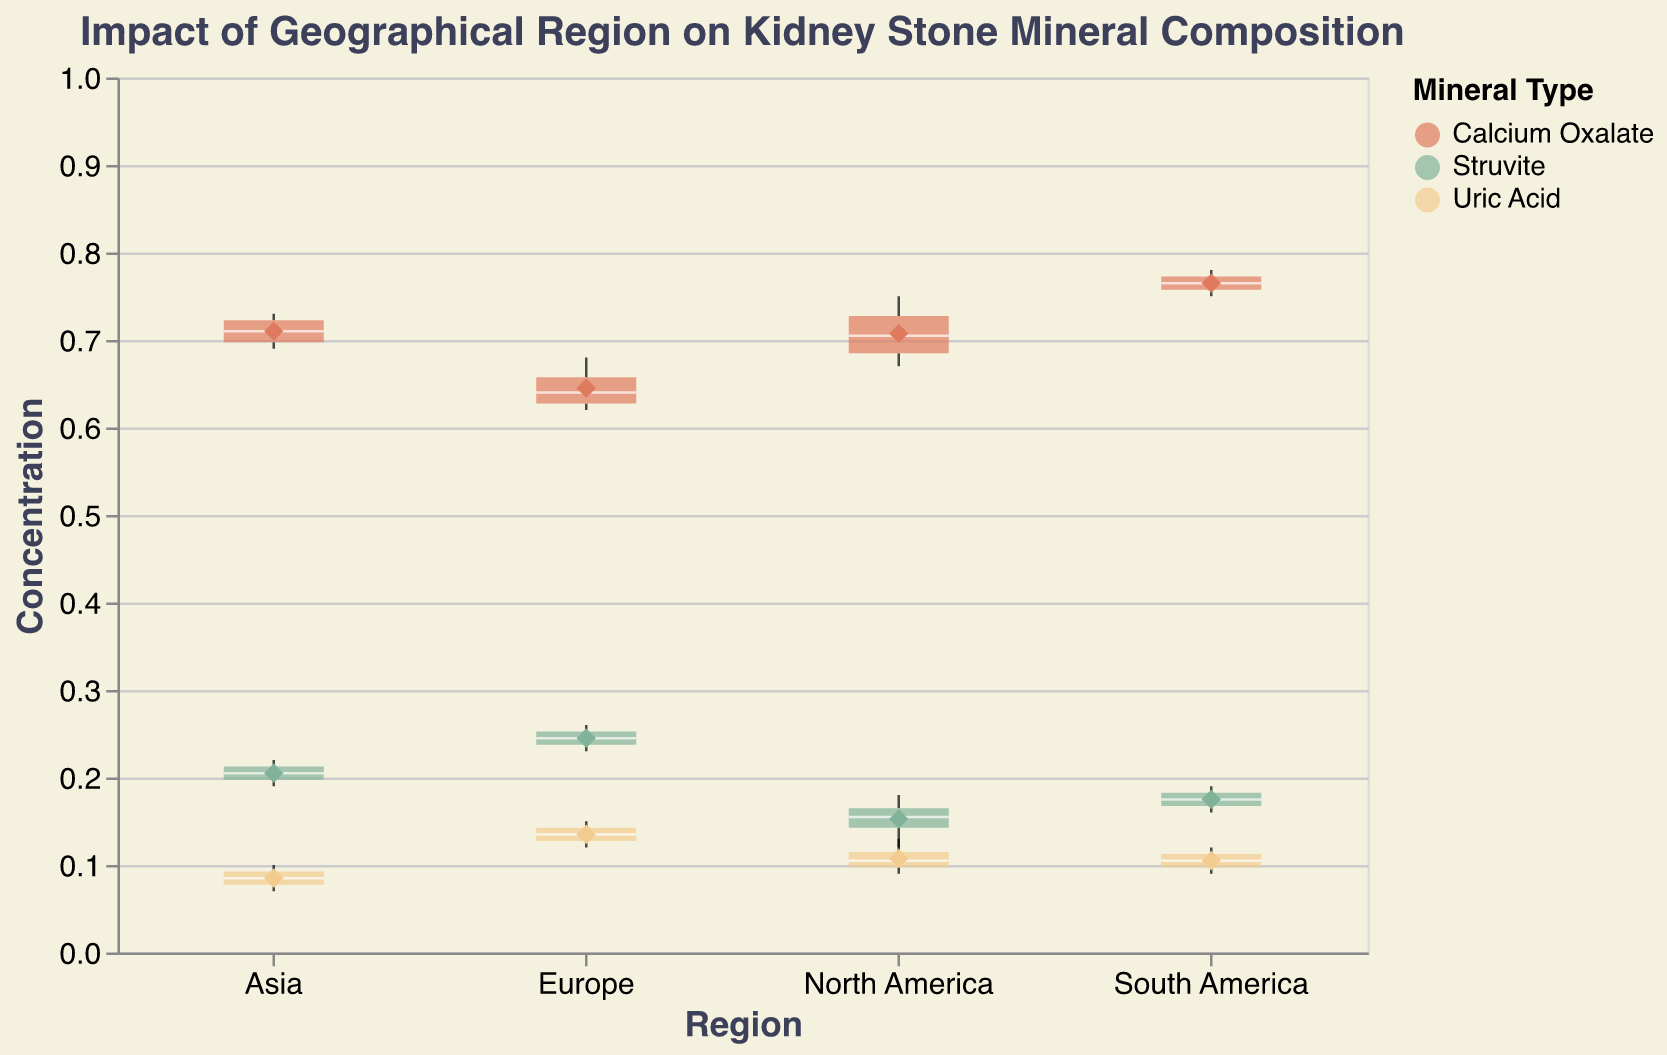What is the title of the plot? The title is displayed at the top of the plot and reads "Impact of Geographical Region on Kidney Stone Mineral Composition".
Answer: Impact of Geographical Region on Kidney Stone Mineral Composition What regions are compared in the plot? The x-axis categories represent the regions being compared in the plot. These regions are North America, Europe, Asia, and South America.
Answer: North America, Europe, Asia, South America What colors represent Calcium Oxalate, Struvite, and Uric Acid in the plot? The legend on the right side of the plot indicates that Calcium Oxalate is represented by a reddish color, Struvite by a greenish color, and Uric Acid by a yellowish color.
Answer: Reddish: Calcium Oxalate, Greenish: Struvite, Yellowish: Uric Acid Which mineral has the highest concentration mean in North America? In North America, the diamond shape represents the mean concentration value for each mineral. Comparing these points, the one for Calcium Oxalate has the highest mean among all the minerals.
Answer: Calcium Oxalate How do the ranges of Calcium Oxalate concentration values compare between North America and Europe? The extent of the boxplots shows the range of concentration values. For North America, the range for Calcium Oxalate is from 0.67 to 0.75. For Europe, it is from 0.62 to 0.68. North America's range is slightly higher and narrower compared to Europe's.
Answer: Higher and narrower in North America Which region has the widest range for Struvite concentration values? By comparing the extents of the boxplots for Struvite in each region, Europe has the widest range (0.23 to 0.26), while other regions have narrower ranges.
Answer: Europe What is the median concentration of Uric Acid in Europe? The line inside the box of the boxplot represents the median value. For Uric Acid in Europe, this median line is around 0.13.
Answer: 0.13 What is the highest concentration value for Calcium Oxalate across all regions? The highest whisker in the boxplots of Calcium Oxalate represents the maximum value. This occurs in South America with a value of 0.78.
Answer: 0.78 Which mineral shows more variation in concentration in Asia, Struvite or Uric Acid? The extent of the boxplot and the distance between the whiskers indicate variation. Struvite in Asia varies from 0.19 to 0.22, whereas Uric Acid varies from 0.07 to 0.10. Struvite shows less variation compared to Uric Acid.
Answer: Uric Acid 